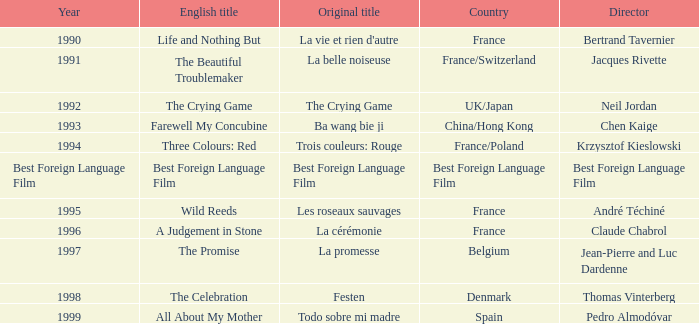What's the Original Title of the English title A Judgement in Stone? La cérémonie. 